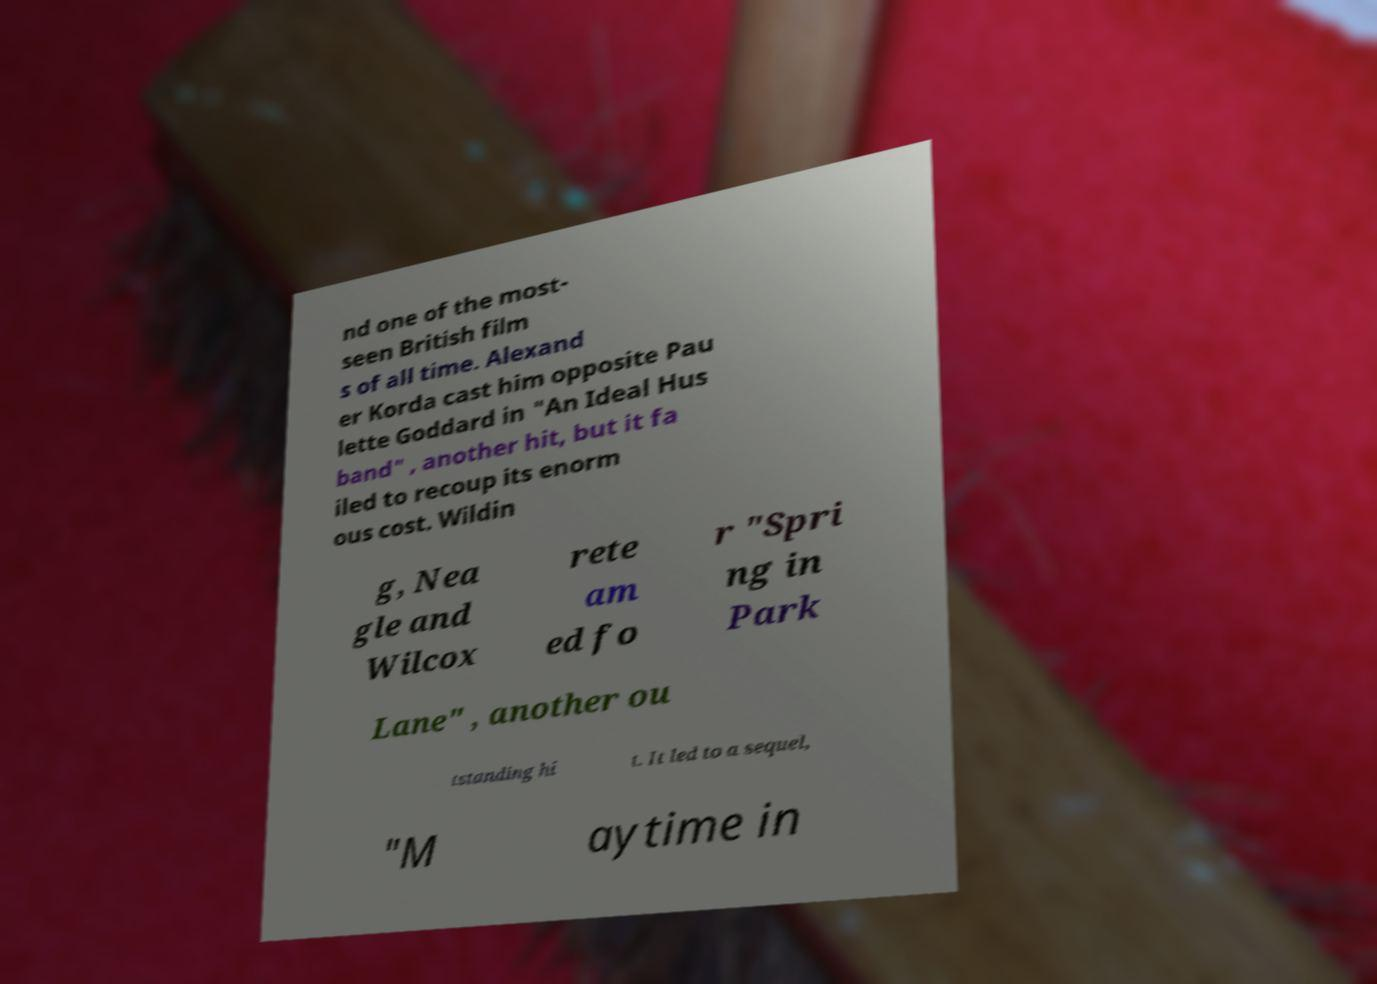Please read and relay the text visible in this image. What does it say? nd one of the most- seen British film s of all time. Alexand er Korda cast him opposite Pau lette Goddard in "An Ideal Hus band" , another hit, but it fa iled to recoup its enorm ous cost. Wildin g, Nea gle and Wilcox rete am ed fo r "Spri ng in Park Lane" , another ou tstanding hi t. It led to a sequel, "M aytime in 